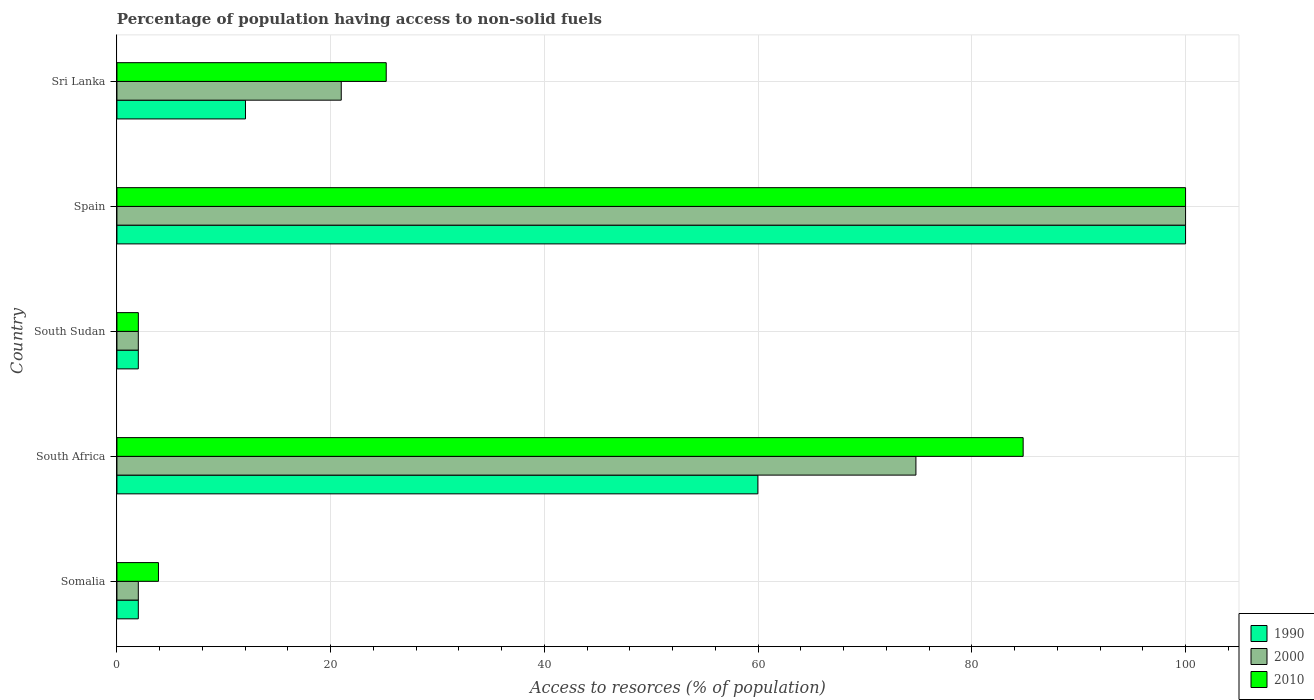Are the number of bars on each tick of the Y-axis equal?
Your response must be concise. Yes. How many bars are there on the 4th tick from the top?
Your answer should be compact. 3. What is the percentage of population having access to non-solid fuels in 2000 in Sri Lanka?
Make the answer very short. 20.99. Across all countries, what is the minimum percentage of population having access to non-solid fuels in 2000?
Make the answer very short. 2. In which country was the percentage of population having access to non-solid fuels in 1990 maximum?
Your answer should be very brief. Spain. In which country was the percentage of population having access to non-solid fuels in 2000 minimum?
Keep it short and to the point. Somalia. What is the total percentage of population having access to non-solid fuels in 1990 in the graph?
Make the answer very short. 176.01. What is the difference between the percentage of population having access to non-solid fuels in 2000 in Sri Lanka and the percentage of population having access to non-solid fuels in 2010 in Spain?
Provide a succinct answer. -79.01. What is the average percentage of population having access to non-solid fuels in 2010 per country?
Your answer should be very brief. 43.18. In how many countries, is the percentage of population having access to non-solid fuels in 2000 greater than 40 %?
Your answer should be compact. 2. What is the ratio of the percentage of population having access to non-solid fuels in 2000 in Spain to that in Sri Lanka?
Offer a terse response. 4.76. Is the difference between the percentage of population having access to non-solid fuels in 2000 in South Sudan and Spain greater than the difference between the percentage of population having access to non-solid fuels in 1990 in South Sudan and Spain?
Your response must be concise. No. What is the difference between the highest and the second highest percentage of population having access to non-solid fuels in 2000?
Offer a terse response. 25.23. What is the difference between the highest and the lowest percentage of population having access to non-solid fuels in 2010?
Give a very brief answer. 98. In how many countries, is the percentage of population having access to non-solid fuels in 2010 greater than the average percentage of population having access to non-solid fuels in 2010 taken over all countries?
Provide a succinct answer. 2. Is the sum of the percentage of population having access to non-solid fuels in 2010 in Spain and Sri Lanka greater than the maximum percentage of population having access to non-solid fuels in 1990 across all countries?
Offer a very short reply. Yes. What does the 3rd bar from the top in Somalia represents?
Your answer should be very brief. 1990. What does the 2nd bar from the bottom in Somalia represents?
Offer a very short reply. 2000. What is the difference between two consecutive major ticks on the X-axis?
Make the answer very short. 20. Does the graph contain grids?
Your response must be concise. Yes. Where does the legend appear in the graph?
Provide a succinct answer. Bottom right. What is the title of the graph?
Provide a short and direct response. Percentage of population having access to non-solid fuels. What is the label or title of the X-axis?
Your answer should be very brief. Access to resorces (% of population). What is the label or title of the Y-axis?
Make the answer very short. Country. What is the Access to resorces (% of population) of 1990 in Somalia?
Your response must be concise. 2. What is the Access to resorces (% of population) in 2000 in Somalia?
Provide a succinct answer. 2. What is the Access to resorces (% of population) in 2010 in Somalia?
Make the answer very short. 3.89. What is the Access to resorces (% of population) in 1990 in South Africa?
Your response must be concise. 59.98. What is the Access to resorces (% of population) in 2000 in South Africa?
Provide a short and direct response. 74.77. What is the Access to resorces (% of population) in 2010 in South Africa?
Offer a very short reply. 84.8. What is the Access to resorces (% of population) of 1990 in South Sudan?
Ensure brevity in your answer.  2. What is the Access to resorces (% of population) in 2000 in South Sudan?
Provide a succinct answer. 2. What is the Access to resorces (% of population) of 2010 in South Sudan?
Make the answer very short. 2. What is the Access to resorces (% of population) of 1990 in Spain?
Offer a very short reply. 100. What is the Access to resorces (% of population) in 2000 in Spain?
Provide a succinct answer. 100. What is the Access to resorces (% of population) of 2010 in Spain?
Your answer should be compact. 100. What is the Access to resorces (% of population) in 1990 in Sri Lanka?
Ensure brevity in your answer.  12.03. What is the Access to resorces (% of population) of 2000 in Sri Lanka?
Give a very brief answer. 20.99. What is the Access to resorces (% of population) in 2010 in Sri Lanka?
Make the answer very short. 25.2. Across all countries, what is the maximum Access to resorces (% of population) of 2000?
Make the answer very short. 100. Across all countries, what is the minimum Access to resorces (% of population) in 1990?
Your answer should be compact. 2. Across all countries, what is the minimum Access to resorces (% of population) in 2000?
Your response must be concise. 2. Across all countries, what is the minimum Access to resorces (% of population) in 2010?
Ensure brevity in your answer.  2. What is the total Access to resorces (% of population) of 1990 in the graph?
Your response must be concise. 176.01. What is the total Access to resorces (% of population) of 2000 in the graph?
Keep it short and to the point. 199.76. What is the total Access to resorces (% of population) in 2010 in the graph?
Offer a very short reply. 215.89. What is the difference between the Access to resorces (% of population) in 1990 in Somalia and that in South Africa?
Your answer should be compact. -57.98. What is the difference between the Access to resorces (% of population) in 2000 in Somalia and that in South Africa?
Provide a succinct answer. -72.77. What is the difference between the Access to resorces (% of population) in 2010 in Somalia and that in South Africa?
Your answer should be very brief. -80.92. What is the difference between the Access to resorces (% of population) of 1990 in Somalia and that in South Sudan?
Your response must be concise. 0. What is the difference between the Access to resorces (% of population) of 2010 in Somalia and that in South Sudan?
Make the answer very short. 1.88. What is the difference between the Access to resorces (% of population) in 1990 in Somalia and that in Spain?
Give a very brief answer. -98. What is the difference between the Access to resorces (% of population) of 2000 in Somalia and that in Spain?
Give a very brief answer. -98. What is the difference between the Access to resorces (% of population) of 2010 in Somalia and that in Spain?
Ensure brevity in your answer.  -96.11. What is the difference between the Access to resorces (% of population) of 1990 in Somalia and that in Sri Lanka?
Your answer should be compact. -10.03. What is the difference between the Access to resorces (% of population) of 2000 in Somalia and that in Sri Lanka?
Your answer should be compact. -18.99. What is the difference between the Access to resorces (% of population) in 2010 in Somalia and that in Sri Lanka?
Your answer should be compact. -21.31. What is the difference between the Access to resorces (% of population) of 1990 in South Africa and that in South Sudan?
Offer a very short reply. 57.98. What is the difference between the Access to resorces (% of population) of 2000 in South Africa and that in South Sudan?
Ensure brevity in your answer.  72.77. What is the difference between the Access to resorces (% of population) in 2010 in South Africa and that in South Sudan?
Ensure brevity in your answer.  82.8. What is the difference between the Access to resorces (% of population) in 1990 in South Africa and that in Spain?
Give a very brief answer. -40.02. What is the difference between the Access to resorces (% of population) of 2000 in South Africa and that in Spain?
Your answer should be compact. -25.23. What is the difference between the Access to resorces (% of population) in 2010 in South Africa and that in Spain?
Your answer should be very brief. -15.2. What is the difference between the Access to resorces (% of population) of 1990 in South Africa and that in Sri Lanka?
Provide a succinct answer. 47.95. What is the difference between the Access to resorces (% of population) of 2000 in South Africa and that in Sri Lanka?
Your answer should be very brief. 53.78. What is the difference between the Access to resorces (% of population) in 2010 in South Africa and that in Sri Lanka?
Keep it short and to the point. 59.6. What is the difference between the Access to resorces (% of population) of 1990 in South Sudan and that in Spain?
Provide a short and direct response. -98. What is the difference between the Access to resorces (% of population) in 2000 in South Sudan and that in Spain?
Make the answer very short. -98. What is the difference between the Access to resorces (% of population) in 2010 in South Sudan and that in Spain?
Keep it short and to the point. -98. What is the difference between the Access to resorces (% of population) of 1990 in South Sudan and that in Sri Lanka?
Your answer should be compact. -10.03. What is the difference between the Access to resorces (% of population) of 2000 in South Sudan and that in Sri Lanka?
Provide a short and direct response. -18.99. What is the difference between the Access to resorces (% of population) of 2010 in South Sudan and that in Sri Lanka?
Provide a short and direct response. -23.2. What is the difference between the Access to resorces (% of population) in 1990 in Spain and that in Sri Lanka?
Offer a very short reply. 87.97. What is the difference between the Access to resorces (% of population) in 2000 in Spain and that in Sri Lanka?
Provide a short and direct response. 79.01. What is the difference between the Access to resorces (% of population) of 2010 in Spain and that in Sri Lanka?
Ensure brevity in your answer.  74.8. What is the difference between the Access to resorces (% of population) of 1990 in Somalia and the Access to resorces (% of population) of 2000 in South Africa?
Make the answer very short. -72.77. What is the difference between the Access to resorces (% of population) in 1990 in Somalia and the Access to resorces (% of population) in 2010 in South Africa?
Keep it short and to the point. -82.8. What is the difference between the Access to resorces (% of population) in 2000 in Somalia and the Access to resorces (% of population) in 2010 in South Africa?
Offer a terse response. -82.8. What is the difference between the Access to resorces (% of population) in 1990 in Somalia and the Access to resorces (% of population) in 2010 in South Sudan?
Provide a succinct answer. -0. What is the difference between the Access to resorces (% of population) in 2000 in Somalia and the Access to resorces (% of population) in 2010 in South Sudan?
Provide a succinct answer. -0. What is the difference between the Access to resorces (% of population) of 1990 in Somalia and the Access to resorces (% of population) of 2000 in Spain?
Provide a succinct answer. -98. What is the difference between the Access to resorces (% of population) in 1990 in Somalia and the Access to resorces (% of population) in 2010 in Spain?
Provide a short and direct response. -98. What is the difference between the Access to resorces (% of population) in 2000 in Somalia and the Access to resorces (% of population) in 2010 in Spain?
Ensure brevity in your answer.  -98. What is the difference between the Access to resorces (% of population) of 1990 in Somalia and the Access to resorces (% of population) of 2000 in Sri Lanka?
Provide a short and direct response. -18.99. What is the difference between the Access to resorces (% of population) in 1990 in Somalia and the Access to resorces (% of population) in 2010 in Sri Lanka?
Give a very brief answer. -23.2. What is the difference between the Access to resorces (% of population) of 2000 in Somalia and the Access to resorces (% of population) of 2010 in Sri Lanka?
Provide a succinct answer. -23.2. What is the difference between the Access to resorces (% of population) of 1990 in South Africa and the Access to resorces (% of population) of 2000 in South Sudan?
Your answer should be compact. 57.98. What is the difference between the Access to resorces (% of population) in 1990 in South Africa and the Access to resorces (% of population) in 2010 in South Sudan?
Offer a terse response. 57.97. What is the difference between the Access to resorces (% of population) of 2000 in South Africa and the Access to resorces (% of population) of 2010 in South Sudan?
Provide a short and direct response. 72.76. What is the difference between the Access to resorces (% of population) of 1990 in South Africa and the Access to resorces (% of population) of 2000 in Spain?
Give a very brief answer. -40.02. What is the difference between the Access to resorces (% of population) of 1990 in South Africa and the Access to resorces (% of population) of 2010 in Spain?
Ensure brevity in your answer.  -40.02. What is the difference between the Access to resorces (% of population) in 2000 in South Africa and the Access to resorces (% of population) in 2010 in Spain?
Provide a succinct answer. -25.23. What is the difference between the Access to resorces (% of population) of 1990 in South Africa and the Access to resorces (% of population) of 2000 in Sri Lanka?
Provide a succinct answer. 38.99. What is the difference between the Access to resorces (% of population) in 1990 in South Africa and the Access to resorces (% of population) in 2010 in Sri Lanka?
Provide a short and direct response. 34.78. What is the difference between the Access to resorces (% of population) in 2000 in South Africa and the Access to resorces (% of population) in 2010 in Sri Lanka?
Provide a succinct answer. 49.57. What is the difference between the Access to resorces (% of population) of 1990 in South Sudan and the Access to resorces (% of population) of 2000 in Spain?
Make the answer very short. -98. What is the difference between the Access to resorces (% of population) in 1990 in South Sudan and the Access to resorces (% of population) in 2010 in Spain?
Offer a very short reply. -98. What is the difference between the Access to resorces (% of population) of 2000 in South Sudan and the Access to resorces (% of population) of 2010 in Spain?
Make the answer very short. -98. What is the difference between the Access to resorces (% of population) in 1990 in South Sudan and the Access to resorces (% of population) in 2000 in Sri Lanka?
Ensure brevity in your answer.  -18.99. What is the difference between the Access to resorces (% of population) of 1990 in South Sudan and the Access to resorces (% of population) of 2010 in Sri Lanka?
Your answer should be compact. -23.2. What is the difference between the Access to resorces (% of population) of 2000 in South Sudan and the Access to resorces (% of population) of 2010 in Sri Lanka?
Your answer should be compact. -23.2. What is the difference between the Access to resorces (% of population) in 1990 in Spain and the Access to resorces (% of population) in 2000 in Sri Lanka?
Your answer should be very brief. 79.01. What is the difference between the Access to resorces (% of population) of 1990 in Spain and the Access to resorces (% of population) of 2010 in Sri Lanka?
Provide a short and direct response. 74.8. What is the difference between the Access to resorces (% of population) of 2000 in Spain and the Access to resorces (% of population) of 2010 in Sri Lanka?
Ensure brevity in your answer.  74.8. What is the average Access to resorces (% of population) of 1990 per country?
Your answer should be compact. 35.2. What is the average Access to resorces (% of population) of 2000 per country?
Ensure brevity in your answer.  39.95. What is the average Access to resorces (% of population) of 2010 per country?
Offer a terse response. 43.18. What is the difference between the Access to resorces (% of population) of 1990 and Access to resorces (% of population) of 2000 in Somalia?
Your answer should be compact. 0. What is the difference between the Access to resorces (% of population) in 1990 and Access to resorces (% of population) in 2010 in Somalia?
Make the answer very short. -1.89. What is the difference between the Access to resorces (% of population) of 2000 and Access to resorces (% of population) of 2010 in Somalia?
Ensure brevity in your answer.  -1.89. What is the difference between the Access to resorces (% of population) of 1990 and Access to resorces (% of population) of 2000 in South Africa?
Your answer should be compact. -14.79. What is the difference between the Access to resorces (% of population) of 1990 and Access to resorces (% of population) of 2010 in South Africa?
Ensure brevity in your answer.  -24.82. What is the difference between the Access to resorces (% of population) of 2000 and Access to resorces (% of population) of 2010 in South Africa?
Offer a terse response. -10.04. What is the difference between the Access to resorces (% of population) in 1990 and Access to resorces (% of population) in 2010 in South Sudan?
Your response must be concise. -0. What is the difference between the Access to resorces (% of population) in 2000 and Access to resorces (% of population) in 2010 in South Sudan?
Offer a very short reply. -0. What is the difference between the Access to resorces (% of population) in 1990 and Access to resorces (% of population) in 2000 in Spain?
Your response must be concise. 0. What is the difference between the Access to resorces (% of population) of 1990 and Access to resorces (% of population) of 2000 in Sri Lanka?
Ensure brevity in your answer.  -8.96. What is the difference between the Access to resorces (% of population) in 1990 and Access to resorces (% of population) in 2010 in Sri Lanka?
Provide a succinct answer. -13.17. What is the difference between the Access to resorces (% of population) of 2000 and Access to resorces (% of population) of 2010 in Sri Lanka?
Offer a terse response. -4.21. What is the ratio of the Access to resorces (% of population) of 1990 in Somalia to that in South Africa?
Make the answer very short. 0.03. What is the ratio of the Access to resorces (% of population) in 2000 in Somalia to that in South Africa?
Make the answer very short. 0.03. What is the ratio of the Access to resorces (% of population) of 2010 in Somalia to that in South Africa?
Make the answer very short. 0.05. What is the ratio of the Access to resorces (% of population) in 1990 in Somalia to that in South Sudan?
Provide a succinct answer. 1. What is the ratio of the Access to resorces (% of population) in 2010 in Somalia to that in South Sudan?
Offer a terse response. 1.94. What is the ratio of the Access to resorces (% of population) of 1990 in Somalia to that in Spain?
Your response must be concise. 0.02. What is the ratio of the Access to resorces (% of population) in 2010 in Somalia to that in Spain?
Your answer should be compact. 0.04. What is the ratio of the Access to resorces (% of population) in 1990 in Somalia to that in Sri Lanka?
Keep it short and to the point. 0.17. What is the ratio of the Access to resorces (% of population) of 2000 in Somalia to that in Sri Lanka?
Offer a terse response. 0.1. What is the ratio of the Access to resorces (% of population) in 2010 in Somalia to that in Sri Lanka?
Make the answer very short. 0.15. What is the ratio of the Access to resorces (% of population) in 1990 in South Africa to that in South Sudan?
Ensure brevity in your answer.  29.99. What is the ratio of the Access to resorces (% of population) in 2000 in South Africa to that in South Sudan?
Offer a very short reply. 37.38. What is the ratio of the Access to resorces (% of population) of 2010 in South Africa to that in South Sudan?
Provide a succinct answer. 42.35. What is the ratio of the Access to resorces (% of population) of 1990 in South Africa to that in Spain?
Keep it short and to the point. 0.6. What is the ratio of the Access to resorces (% of population) of 2000 in South Africa to that in Spain?
Your answer should be compact. 0.75. What is the ratio of the Access to resorces (% of population) of 2010 in South Africa to that in Spain?
Keep it short and to the point. 0.85. What is the ratio of the Access to resorces (% of population) in 1990 in South Africa to that in Sri Lanka?
Make the answer very short. 4.99. What is the ratio of the Access to resorces (% of population) in 2000 in South Africa to that in Sri Lanka?
Your answer should be very brief. 3.56. What is the ratio of the Access to resorces (% of population) of 2010 in South Africa to that in Sri Lanka?
Keep it short and to the point. 3.37. What is the ratio of the Access to resorces (% of population) of 1990 in South Sudan to that in Sri Lanka?
Your answer should be very brief. 0.17. What is the ratio of the Access to resorces (% of population) in 2000 in South Sudan to that in Sri Lanka?
Provide a short and direct response. 0.1. What is the ratio of the Access to resorces (% of population) of 2010 in South Sudan to that in Sri Lanka?
Ensure brevity in your answer.  0.08. What is the ratio of the Access to resorces (% of population) in 1990 in Spain to that in Sri Lanka?
Make the answer very short. 8.31. What is the ratio of the Access to resorces (% of population) of 2000 in Spain to that in Sri Lanka?
Offer a very short reply. 4.76. What is the ratio of the Access to resorces (% of population) of 2010 in Spain to that in Sri Lanka?
Give a very brief answer. 3.97. What is the difference between the highest and the second highest Access to resorces (% of population) in 1990?
Ensure brevity in your answer.  40.02. What is the difference between the highest and the second highest Access to resorces (% of population) in 2000?
Provide a succinct answer. 25.23. What is the difference between the highest and the second highest Access to resorces (% of population) in 2010?
Offer a terse response. 15.2. What is the difference between the highest and the lowest Access to resorces (% of population) in 2010?
Make the answer very short. 98. 